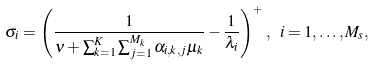<formula> <loc_0><loc_0><loc_500><loc_500>\sigma _ { i } = \left ( \frac { 1 } { \nu + \sum _ { k = 1 } ^ { K } \sum _ { j = 1 } ^ { M _ { k } } \alpha _ { i , k , j } \mu _ { k } } - \frac { 1 } { \lambda _ { i } } \right ) ^ { + } , \ i = 1 , \dots , M _ { s } ,</formula> 